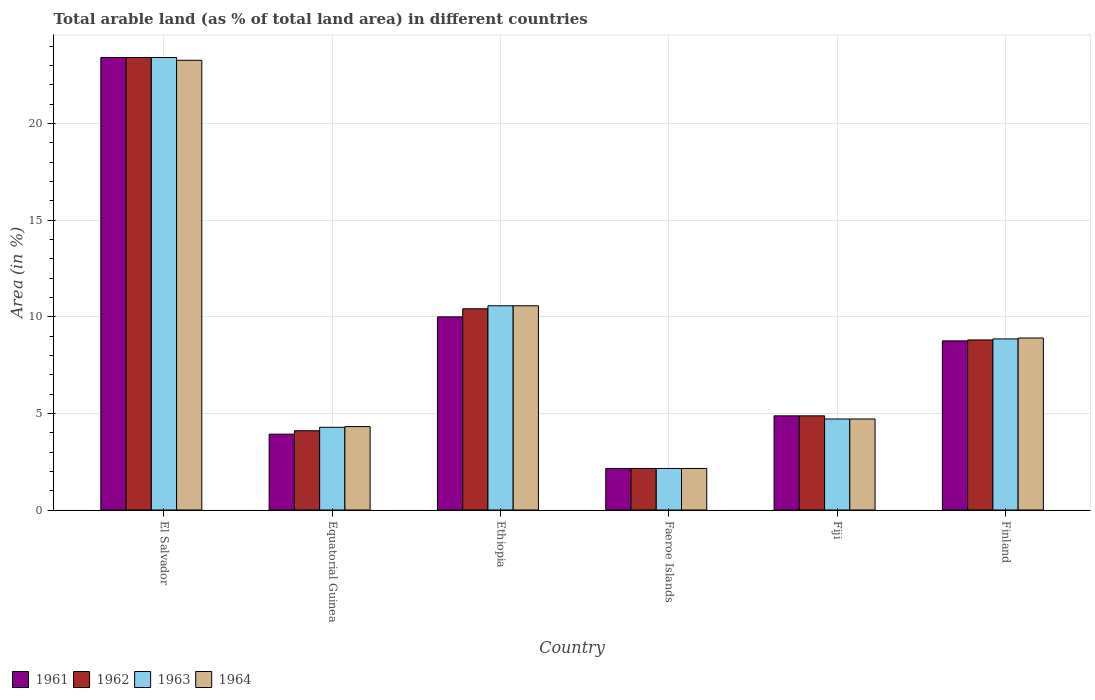What is the label of the 3rd group of bars from the left?
Make the answer very short. Ethiopia. In how many cases, is the number of bars for a given country not equal to the number of legend labels?
Give a very brief answer. 0. What is the percentage of arable land in 1963 in Fiji?
Your answer should be compact. 4.71. Across all countries, what is the maximum percentage of arable land in 1961?
Keep it short and to the point. 23.41. Across all countries, what is the minimum percentage of arable land in 1961?
Offer a very short reply. 2.15. In which country was the percentage of arable land in 1962 maximum?
Your answer should be compact. El Salvador. In which country was the percentage of arable land in 1961 minimum?
Provide a succinct answer. Faeroe Islands. What is the total percentage of arable land in 1964 in the graph?
Your answer should be very brief. 53.89. What is the difference between the percentage of arable land in 1964 in Fiji and that in Finland?
Keep it short and to the point. -4.19. What is the difference between the percentage of arable land in 1961 in El Salvador and the percentage of arable land in 1964 in Finland?
Your answer should be very brief. 14.51. What is the average percentage of arable land in 1963 per country?
Offer a terse response. 8.99. What is the difference between the percentage of arable land of/in 1964 and percentage of arable land of/in 1961 in El Salvador?
Ensure brevity in your answer.  -0.14. What is the ratio of the percentage of arable land in 1961 in Ethiopia to that in Finland?
Your answer should be compact. 1.14. Is the difference between the percentage of arable land in 1964 in El Salvador and Ethiopia greater than the difference between the percentage of arable land in 1961 in El Salvador and Ethiopia?
Offer a very short reply. No. What is the difference between the highest and the second highest percentage of arable land in 1961?
Make the answer very short. -1.24. What is the difference between the highest and the lowest percentage of arable land in 1963?
Provide a short and direct response. 21.26. What does the 1st bar from the left in Equatorial Guinea represents?
Offer a very short reply. 1961. What does the 4th bar from the right in Equatorial Guinea represents?
Your answer should be compact. 1961. How many countries are there in the graph?
Your response must be concise. 6. Does the graph contain any zero values?
Your response must be concise. No. Where does the legend appear in the graph?
Offer a very short reply. Bottom left. How many legend labels are there?
Keep it short and to the point. 4. How are the legend labels stacked?
Offer a terse response. Horizontal. What is the title of the graph?
Your answer should be very brief. Total arable land (as % of total land area) in different countries. Does "1990" appear as one of the legend labels in the graph?
Make the answer very short. No. What is the label or title of the X-axis?
Your response must be concise. Country. What is the label or title of the Y-axis?
Offer a very short reply. Area (in %). What is the Area (in %) of 1961 in El Salvador?
Provide a short and direct response. 23.41. What is the Area (in %) in 1962 in El Salvador?
Offer a terse response. 23.41. What is the Area (in %) in 1963 in El Salvador?
Ensure brevity in your answer.  23.41. What is the Area (in %) in 1964 in El Salvador?
Your answer should be very brief. 23.26. What is the Area (in %) in 1961 in Equatorial Guinea?
Provide a succinct answer. 3.92. What is the Area (in %) of 1962 in Equatorial Guinea?
Your response must be concise. 4.1. What is the Area (in %) of 1963 in Equatorial Guinea?
Offer a very short reply. 4.28. What is the Area (in %) of 1964 in Equatorial Guinea?
Your answer should be very brief. 4.31. What is the Area (in %) of 1961 in Ethiopia?
Give a very brief answer. 9.99. What is the Area (in %) in 1962 in Ethiopia?
Your response must be concise. 10.41. What is the Area (in %) in 1963 in Ethiopia?
Your answer should be compact. 10.56. What is the Area (in %) of 1964 in Ethiopia?
Your answer should be very brief. 10.56. What is the Area (in %) in 1961 in Faeroe Islands?
Your response must be concise. 2.15. What is the Area (in %) of 1962 in Faeroe Islands?
Provide a short and direct response. 2.15. What is the Area (in %) of 1963 in Faeroe Islands?
Ensure brevity in your answer.  2.15. What is the Area (in %) in 1964 in Faeroe Islands?
Offer a very short reply. 2.15. What is the Area (in %) of 1961 in Fiji?
Provide a succinct answer. 4.87. What is the Area (in %) of 1962 in Fiji?
Provide a succinct answer. 4.87. What is the Area (in %) of 1963 in Fiji?
Your answer should be compact. 4.71. What is the Area (in %) of 1964 in Fiji?
Keep it short and to the point. 4.71. What is the Area (in %) of 1961 in Finland?
Your response must be concise. 8.75. What is the Area (in %) in 1962 in Finland?
Give a very brief answer. 8.8. What is the Area (in %) of 1963 in Finland?
Ensure brevity in your answer.  8.85. What is the Area (in %) in 1964 in Finland?
Ensure brevity in your answer.  8.9. Across all countries, what is the maximum Area (in %) of 1961?
Your answer should be compact. 23.41. Across all countries, what is the maximum Area (in %) in 1962?
Your answer should be very brief. 23.41. Across all countries, what is the maximum Area (in %) in 1963?
Give a very brief answer. 23.41. Across all countries, what is the maximum Area (in %) of 1964?
Your answer should be very brief. 23.26. Across all countries, what is the minimum Area (in %) in 1961?
Ensure brevity in your answer.  2.15. Across all countries, what is the minimum Area (in %) in 1962?
Provide a succinct answer. 2.15. Across all countries, what is the minimum Area (in %) in 1963?
Your response must be concise. 2.15. Across all countries, what is the minimum Area (in %) of 1964?
Give a very brief answer. 2.15. What is the total Area (in %) of 1961 in the graph?
Keep it short and to the point. 53.09. What is the total Area (in %) in 1962 in the graph?
Ensure brevity in your answer.  53.73. What is the total Area (in %) of 1963 in the graph?
Your answer should be compact. 53.95. What is the total Area (in %) in 1964 in the graph?
Your response must be concise. 53.89. What is the difference between the Area (in %) in 1961 in El Salvador and that in Equatorial Guinea?
Offer a very short reply. 19.48. What is the difference between the Area (in %) of 1962 in El Salvador and that in Equatorial Guinea?
Provide a short and direct response. 19.31. What is the difference between the Area (in %) of 1963 in El Salvador and that in Equatorial Guinea?
Ensure brevity in your answer.  19.13. What is the difference between the Area (in %) in 1964 in El Salvador and that in Equatorial Guinea?
Give a very brief answer. 18.95. What is the difference between the Area (in %) of 1961 in El Salvador and that in Ethiopia?
Your response must be concise. 13.41. What is the difference between the Area (in %) in 1962 in El Salvador and that in Ethiopia?
Give a very brief answer. 13. What is the difference between the Area (in %) of 1963 in El Salvador and that in Ethiopia?
Your answer should be compact. 12.84. What is the difference between the Area (in %) in 1964 in El Salvador and that in Ethiopia?
Your answer should be very brief. 12.7. What is the difference between the Area (in %) of 1961 in El Salvador and that in Faeroe Islands?
Ensure brevity in your answer.  21.26. What is the difference between the Area (in %) of 1962 in El Salvador and that in Faeroe Islands?
Give a very brief answer. 21.26. What is the difference between the Area (in %) in 1963 in El Salvador and that in Faeroe Islands?
Your response must be concise. 21.26. What is the difference between the Area (in %) in 1964 in El Salvador and that in Faeroe Islands?
Give a very brief answer. 21.11. What is the difference between the Area (in %) in 1961 in El Salvador and that in Fiji?
Your answer should be very brief. 18.53. What is the difference between the Area (in %) in 1962 in El Salvador and that in Fiji?
Provide a short and direct response. 18.53. What is the difference between the Area (in %) of 1963 in El Salvador and that in Fiji?
Keep it short and to the point. 18.7. What is the difference between the Area (in %) in 1964 in El Salvador and that in Fiji?
Your response must be concise. 18.55. What is the difference between the Area (in %) in 1961 in El Salvador and that in Finland?
Provide a succinct answer. 14.66. What is the difference between the Area (in %) of 1962 in El Salvador and that in Finland?
Offer a very short reply. 14.61. What is the difference between the Area (in %) in 1963 in El Salvador and that in Finland?
Make the answer very short. 14.56. What is the difference between the Area (in %) in 1964 in El Salvador and that in Finland?
Provide a short and direct response. 14.37. What is the difference between the Area (in %) in 1961 in Equatorial Guinea and that in Ethiopia?
Offer a terse response. -6.07. What is the difference between the Area (in %) of 1962 in Equatorial Guinea and that in Ethiopia?
Provide a short and direct response. -6.31. What is the difference between the Area (in %) in 1963 in Equatorial Guinea and that in Ethiopia?
Give a very brief answer. -6.29. What is the difference between the Area (in %) of 1964 in Equatorial Guinea and that in Ethiopia?
Your response must be concise. -6.25. What is the difference between the Area (in %) in 1961 in Equatorial Guinea and that in Faeroe Islands?
Your response must be concise. 1.77. What is the difference between the Area (in %) in 1962 in Equatorial Guinea and that in Faeroe Islands?
Make the answer very short. 1.95. What is the difference between the Area (in %) of 1963 in Equatorial Guinea and that in Faeroe Islands?
Your response must be concise. 2.13. What is the difference between the Area (in %) of 1964 in Equatorial Guinea and that in Faeroe Islands?
Give a very brief answer. 2.16. What is the difference between the Area (in %) in 1961 in Equatorial Guinea and that in Fiji?
Your answer should be very brief. -0.95. What is the difference between the Area (in %) of 1962 in Equatorial Guinea and that in Fiji?
Give a very brief answer. -0.77. What is the difference between the Area (in %) in 1963 in Equatorial Guinea and that in Fiji?
Provide a short and direct response. -0.43. What is the difference between the Area (in %) in 1964 in Equatorial Guinea and that in Fiji?
Keep it short and to the point. -0.39. What is the difference between the Area (in %) in 1961 in Equatorial Guinea and that in Finland?
Your answer should be very brief. -4.83. What is the difference between the Area (in %) in 1962 in Equatorial Guinea and that in Finland?
Keep it short and to the point. -4.7. What is the difference between the Area (in %) in 1963 in Equatorial Guinea and that in Finland?
Offer a terse response. -4.57. What is the difference between the Area (in %) of 1964 in Equatorial Guinea and that in Finland?
Give a very brief answer. -4.58. What is the difference between the Area (in %) of 1961 in Ethiopia and that in Faeroe Islands?
Give a very brief answer. 7.84. What is the difference between the Area (in %) of 1962 in Ethiopia and that in Faeroe Islands?
Your response must be concise. 8.26. What is the difference between the Area (in %) in 1963 in Ethiopia and that in Faeroe Islands?
Your answer should be very brief. 8.41. What is the difference between the Area (in %) in 1964 in Ethiopia and that in Faeroe Islands?
Offer a terse response. 8.41. What is the difference between the Area (in %) of 1961 in Ethiopia and that in Fiji?
Your answer should be very brief. 5.12. What is the difference between the Area (in %) in 1962 in Ethiopia and that in Fiji?
Keep it short and to the point. 5.54. What is the difference between the Area (in %) in 1963 in Ethiopia and that in Fiji?
Your response must be concise. 5.86. What is the difference between the Area (in %) of 1964 in Ethiopia and that in Fiji?
Keep it short and to the point. 5.86. What is the difference between the Area (in %) of 1961 in Ethiopia and that in Finland?
Ensure brevity in your answer.  1.24. What is the difference between the Area (in %) of 1962 in Ethiopia and that in Finland?
Make the answer very short. 1.61. What is the difference between the Area (in %) of 1963 in Ethiopia and that in Finland?
Make the answer very short. 1.71. What is the difference between the Area (in %) of 1964 in Ethiopia and that in Finland?
Provide a short and direct response. 1.67. What is the difference between the Area (in %) in 1961 in Faeroe Islands and that in Fiji?
Offer a terse response. -2.72. What is the difference between the Area (in %) in 1962 in Faeroe Islands and that in Fiji?
Offer a very short reply. -2.72. What is the difference between the Area (in %) in 1963 in Faeroe Islands and that in Fiji?
Offer a very short reply. -2.56. What is the difference between the Area (in %) in 1964 in Faeroe Islands and that in Fiji?
Offer a very short reply. -2.56. What is the difference between the Area (in %) of 1961 in Faeroe Islands and that in Finland?
Your answer should be very brief. -6.6. What is the difference between the Area (in %) in 1962 in Faeroe Islands and that in Finland?
Give a very brief answer. -6.65. What is the difference between the Area (in %) in 1963 in Faeroe Islands and that in Finland?
Offer a very short reply. -6.7. What is the difference between the Area (in %) of 1964 in Faeroe Islands and that in Finland?
Your answer should be very brief. -6.75. What is the difference between the Area (in %) of 1961 in Fiji and that in Finland?
Your answer should be very brief. -3.88. What is the difference between the Area (in %) of 1962 in Fiji and that in Finland?
Offer a very short reply. -3.92. What is the difference between the Area (in %) in 1963 in Fiji and that in Finland?
Give a very brief answer. -4.14. What is the difference between the Area (in %) of 1964 in Fiji and that in Finland?
Make the answer very short. -4.19. What is the difference between the Area (in %) in 1961 in El Salvador and the Area (in %) in 1962 in Equatorial Guinea?
Provide a short and direct response. 19.31. What is the difference between the Area (in %) in 1961 in El Salvador and the Area (in %) in 1963 in Equatorial Guinea?
Your answer should be compact. 19.13. What is the difference between the Area (in %) of 1961 in El Salvador and the Area (in %) of 1964 in Equatorial Guinea?
Provide a succinct answer. 19.09. What is the difference between the Area (in %) of 1962 in El Salvador and the Area (in %) of 1963 in Equatorial Guinea?
Your answer should be compact. 19.13. What is the difference between the Area (in %) of 1962 in El Salvador and the Area (in %) of 1964 in Equatorial Guinea?
Provide a short and direct response. 19.09. What is the difference between the Area (in %) of 1963 in El Salvador and the Area (in %) of 1964 in Equatorial Guinea?
Make the answer very short. 19.09. What is the difference between the Area (in %) in 1961 in El Salvador and the Area (in %) in 1962 in Ethiopia?
Your response must be concise. 13. What is the difference between the Area (in %) in 1961 in El Salvador and the Area (in %) in 1963 in Ethiopia?
Keep it short and to the point. 12.84. What is the difference between the Area (in %) in 1961 in El Salvador and the Area (in %) in 1964 in Ethiopia?
Provide a succinct answer. 12.84. What is the difference between the Area (in %) of 1962 in El Salvador and the Area (in %) of 1963 in Ethiopia?
Offer a very short reply. 12.84. What is the difference between the Area (in %) in 1962 in El Salvador and the Area (in %) in 1964 in Ethiopia?
Provide a succinct answer. 12.84. What is the difference between the Area (in %) of 1963 in El Salvador and the Area (in %) of 1964 in Ethiopia?
Offer a very short reply. 12.84. What is the difference between the Area (in %) in 1961 in El Salvador and the Area (in %) in 1962 in Faeroe Islands?
Keep it short and to the point. 21.26. What is the difference between the Area (in %) of 1961 in El Salvador and the Area (in %) of 1963 in Faeroe Islands?
Make the answer very short. 21.26. What is the difference between the Area (in %) in 1961 in El Salvador and the Area (in %) in 1964 in Faeroe Islands?
Offer a very short reply. 21.26. What is the difference between the Area (in %) in 1962 in El Salvador and the Area (in %) in 1963 in Faeroe Islands?
Ensure brevity in your answer.  21.26. What is the difference between the Area (in %) of 1962 in El Salvador and the Area (in %) of 1964 in Faeroe Islands?
Give a very brief answer. 21.26. What is the difference between the Area (in %) in 1963 in El Salvador and the Area (in %) in 1964 in Faeroe Islands?
Provide a short and direct response. 21.26. What is the difference between the Area (in %) in 1961 in El Salvador and the Area (in %) in 1962 in Fiji?
Ensure brevity in your answer.  18.53. What is the difference between the Area (in %) in 1961 in El Salvador and the Area (in %) in 1963 in Fiji?
Your answer should be compact. 18.7. What is the difference between the Area (in %) of 1961 in El Salvador and the Area (in %) of 1964 in Fiji?
Provide a short and direct response. 18.7. What is the difference between the Area (in %) in 1962 in El Salvador and the Area (in %) in 1963 in Fiji?
Your response must be concise. 18.7. What is the difference between the Area (in %) in 1962 in El Salvador and the Area (in %) in 1964 in Fiji?
Your answer should be compact. 18.7. What is the difference between the Area (in %) in 1963 in El Salvador and the Area (in %) in 1964 in Fiji?
Your response must be concise. 18.7. What is the difference between the Area (in %) in 1961 in El Salvador and the Area (in %) in 1962 in Finland?
Give a very brief answer. 14.61. What is the difference between the Area (in %) in 1961 in El Salvador and the Area (in %) in 1963 in Finland?
Give a very brief answer. 14.56. What is the difference between the Area (in %) of 1961 in El Salvador and the Area (in %) of 1964 in Finland?
Your answer should be compact. 14.51. What is the difference between the Area (in %) of 1962 in El Salvador and the Area (in %) of 1963 in Finland?
Your answer should be compact. 14.56. What is the difference between the Area (in %) in 1962 in El Salvador and the Area (in %) in 1964 in Finland?
Your response must be concise. 14.51. What is the difference between the Area (in %) of 1963 in El Salvador and the Area (in %) of 1964 in Finland?
Your answer should be compact. 14.51. What is the difference between the Area (in %) of 1961 in Equatorial Guinea and the Area (in %) of 1962 in Ethiopia?
Ensure brevity in your answer.  -6.49. What is the difference between the Area (in %) in 1961 in Equatorial Guinea and the Area (in %) in 1963 in Ethiopia?
Give a very brief answer. -6.64. What is the difference between the Area (in %) of 1961 in Equatorial Guinea and the Area (in %) of 1964 in Ethiopia?
Provide a short and direct response. -6.64. What is the difference between the Area (in %) of 1962 in Equatorial Guinea and the Area (in %) of 1963 in Ethiopia?
Make the answer very short. -6.46. What is the difference between the Area (in %) in 1962 in Equatorial Guinea and the Area (in %) in 1964 in Ethiopia?
Your answer should be very brief. -6.46. What is the difference between the Area (in %) in 1963 in Equatorial Guinea and the Area (in %) in 1964 in Ethiopia?
Keep it short and to the point. -6.29. What is the difference between the Area (in %) in 1961 in Equatorial Guinea and the Area (in %) in 1962 in Faeroe Islands?
Give a very brief answer. 1.77. What is the difference between the Area (in %) of 1961 in Equatorial Guinea and the Area (in %) of 1963 in Faeroe Islands?
Keep it short and to the point. 1.77. What is the difference between the Area (in %) of 1961 in Equatorial Guinea and the Area (in %) of 1964 in Faeroe Islands?
Your answer should be compact. 1.77. What is the difference between the Area (in %) in 1962 in Equatorial Guinea and the Area (in %) in 1963 in Faeroe Islands?
Offer a terse response. 1.95. What is the difference between the Area (in %) in 1962 in Equatorial Guinea and the Area (in %) in 1964 in Faeroe Islands?
Your answer should be very brief. 1.95. What is the difference between the Area (in %) in 1963 in Equatorial Guinea and the Area (in %) in 1964 in Faeroe Islands?
Your answer should be very brief. 2.13. What is the difference between the Area (in %) in 1961 in Equatorial Guinea and the Area (in %) in 1962 in Fiji?
Give a very brief answer. -0.95. What is the difference between the Area (in %) of 1961 in Equatorial Guinea and the Area (in %) of 1963 in Fiji?
Offer a very short reply. -0.79. What is the difference between the Area (in %) of 1961 in Equatorial Guinea and the Area (in %) of 1964 in Fiji?
Provide a succinct answer. -0.79. What is the difference between the Area (in %) of 1962 in Equatorial Guinea and the Area (in %) of 1963 in Fiji?
Offer a very short reply. -0.61. What is the difference between the Area (in %) in 1962 in Equatorial Guinea and the Area (in %) in 1964 in Fiji?
Your answer should be very brief. -0.61. What is the difference between the Area (in %) of 1963 in Equatorial Guinea and the Area (in %) of 1964 in Fiji?
Offer a terse response. -0.43. What is the difference between the Area (in %) in 1961 in Equatorial Guinea and the Area (in %) in 1962 in Finland?
Provide a short and direct response. -4.87. What is the difference between the Area (in %) of 1961 in Equatorial Guinea and the Area (in %) of 1963 in Finland?
Your answer should be very brief. -4.93. What is the difference between the Area (in %) in 1961 in Equatorial Guinea and the Area (in %) in 1964 in Finland?
Your answer should be very brief. -4.97. What is the difference between the Area (in %) of 1962 in Equatorial Guinea and the Area (in %) of 1963 in Finland?
Your answer should be compact. -4.75. What is the difference between the Area (in %) of 1962 in Equatorial Guinea and the Area (in %) of 1964 in Finland?
Keep it short and to the point. -4.8. What is the difference between the Area (in %) in 1963 in Equatorial Guinea and the Area (in %) in 1964 in Finland?
Offer a very short reply. -4.62. What is the difference between the Area (in %) of 1961 in Ethiopia and the Area (in %) of 1962 in Faeroe Islands?
Your answer should be very brief. 7.84. What is the difference between the Area (in %) in 1961 in Ethiopia and the Area (in %) in 1963 in Faeroe Islands?
Give a very brief answer. 7.84. What is the difference between the Area (in %) of 1961 in Ethiopia and the Area (in %) of 1964 in Faeroe Islands?
Provide a short and direct response. 7.84. What is the difference between the Area (in %) in 1962 in Ethiopia and the Area (in %) in 1963 in Faeroe Islands?
Ensure brevity in your answer.  8.26. What is the difference between the Area (in %) of 1962 in Ethiopia and the Area (in %) of 1964 in Faeroe Islands?
Offer a very short reply. 8.26. What is the difference between the Area (in %) in 1963 in Ethiopia and the Area (in %) in 1964 in Faeroe Islands?
Your answer should be compact. 8.41. What is the difference between the Area (in %) in 1961 in Ethiopia and the Area (in %) in 1962 in Fiji?
Your answer should be very brief. 5.12. What is the difference between the Area (in %) of 1961 in Ethiopia and the Area (in %) of 1963 in Fiji?
Your answer should be compact. 5.28. What is the difference between the Area (in %) in 1961 in Ethiopia and the Area (in %) in 1964 in Fiji?
Your answer should be very brief. 5.28. What is the difference between the Area (in %) in 1962 in Ethiopia and the Area (in %) in 1963 in Fiji?
Your response must be concise. 5.7. What is the difference between the Area (in %) of 1962 in Ethiopia and the Area (in %) of 1964 in Fiji?
Offer a very short reply. 5.7. What is the difference between the Area (in %) of 1963 in Ethiopia and the Area (in %) of 1964 in Fiji?
Your answer should be very brief. 5.86. What is the difference between the Area (in %) in 1961 in Ethiopia and the Area (in %) in 1962 in Finland?
Make the answer very short. 1.2. What is the difference between the Area (in %) in 1961 in Ethiopia and the Area (in %) in 1963 in Finland?
Your answer should be very brief. 1.14. What is the difference between the Area (in %) of 1961 in Ethiopia and the Area (in %) of 1964 in Finland?
Provide a succinct answer. 1.09. What is the difference between the Area (in %) in 1962 in Ethiopia and the Area (in %) in 1963 in Finland?
Ensure brevity in your answer.  1.56. What is the difference between the Area (in %) in 1962 in Ethiopia and the Area (in %) in 1964 in Finland?
Keep it short and to the point. 1.51. What is the difference between the Area (in %) of 1963 in Ethiopia and the Area (in %) of 1964 in Finland?
Keep it short and to the point. 1.67. What is the difference between the Area (in %) of 1961 in Faeroe Islands and the Area (in %) of 1962 in Fiji?
Provide a succinct answer. -2.72. What is the difference between the Area (in %) of 1961 in Faeroe Islands and the Area (in %) of 1963 in Fiji?
Provide a short and direct response. -2.56. What is the difference between the Area (in %) in 1961 in Faeroe Islands and the Area (in %) in 1964 in Fiji?
Provide a short and direct response. -2.56. What is the difference between the Area (in %) of 1962 in Faeroe Islands and the Area (in %) of 1963 in Fiji?
Make the answer very short. -2.56. What is the difference between the Area (in %) of 1962 in Faeroe Islands and the Area (in %) of 1964 in Fiji?
Give a very brief answer. -2.56. What is the difference between the Area (in %) of 1963 in Faeroe Islands and the Area (in %) of 1964 in Fiji?
Offer a very short reply. -2.56. What is the difference between the Area (in %) in 1961 in Faeroe Islands and the Area (in %) in 1962 in Finland?
Your answer should be compact. -6.65. What is the difference between the Area (in %) of 1961 in Faeroe Islands and the Area (in %) of 1963 in Finland?
Provide a succinct answer. -6.7. What is the difference between the Area (in %) in 1961 in Faeroe Islands and the Area (in %) in 1964 in Finland?
Make the answer very short. -6.75. What is the difference between the Area (in %) of 1962 in Faeroe Islands and the Area (in %) of 1963 in Finland?
Give a very brief answer. -6.7. What is the difference between the Area (in %) in 1962 in Faeroe Islands and the Area (in %) in 1964 in Finland?
Ensure brevity in your answer.  -6.75. What is the difference between the Area (in %) of 1963 in Faeroe Islands and the Area (in %) of 1964 in Finland?
Provide a short and direct response. -6.75. What is the difference between the Area (in %) of 1961 in Fiji and the Area (in %) of 1962 in Finland?
Give a very brief answer. -3.92. What is the difference between the Area (in %) in 1961 in Fiji and the Area (in %) in 1963 in Finland?
Your answer should be compact. -3.98. What is the difference between the Area (in %) of 1961 in Fiji and the Area (in %) of 1964 in Finland?
Ensure brevity in your answer.  -4.02. What is the difference between the Area (in %) in 1962 in Fiji and the Area (in %) in 1963 in Finland?
Your answer should be compact. -3.98. What is the difference between the Area (in %) in 1962 in Fiji and the Area (in %) in 1964 in Finland?
Make the answer very short. -4.02. What is the difference between the Area (in %) in 1963 in Fiji and the Area (in %) in 1964 in Finland?
Ensure brevity in your answer.  -4.19. What is the average Area (in %) in 1961 per country?
Provide a short and direct response. 8.85. What is the average Area (in %) of 1962 per country?
Keep it short and to the point. 8.95. What is the average Area (in %) in 1963 per country?
Give a very brief answer. 8.99. What is the average Area (in %) of 1964 per country?
Provide a succinct answer. 8.98. What is the difference between the Area (in %) of 1961 and Area (in %) of 1962 in El Salvador?
Your response must be concise. 0. What is the difference between the Area (in %) of 1961 and Area (in %) of 1963 in El Salvador?
Offer a terse response. 0. What is the difference between the Area (in %) of 1961 and Area (in %) of 1964 in El Salvador?
Your answer should be compact. 0.14. What is the difference between the Area (in %) of 1962 and Area (in %) of 1964 in El Salvador?
Keep it short and to the point. 0.14. What is the difference between the Area (in %) in 1963 and Area (in %) in 1964 in El Salvador?
Ensure brevity in your answer.  0.14. What is the difference between the Area (in %) of 1961 and Area (in %) of 1962 in Equatorial Guinea?
Your response must be concise. -0.18. What is the difference between the Area (in %) in 1961 and Area (in %) in 1963 in Equatorial Guinea?
Offer a terse response. -0.36. What is the difference between the Area (in %) of 1961 and Area (in %) of 1964 in Equatorial Guinea?
Your answer should be compact. -0.39. What is the difference between the Area (in %) of 1962 and Area (in %) of 1963 in Equatorial Guinea?
Keep it short and to the point. -0.18. What is the difference between the Area (in %) in 1962 and Area (in %) in 1964 in Equatorial Guinea?
Offer a terse response. -0.21. What is the difference between the Area (in %) in 1963 and Area (in %) in 1964 in Equatorial Guinea?
Ensure brevity in your answer.  -0.04. What is the difference between the Area (in %) of 1961 and Area (in %) of 1962 in Ethiopia?
Give a very brief answer. -0.42. What is the difference between the Area (in %) of 1961 and Area (in %) of 1963 in Ethiopia?
Offer a very short reply. -0.57. What is the difference between the Area (in %) in 1961 and Area (in %) in 1964 in Ethiopia?
Offer a terse response. -0.57. What is the difference between the Area (in %) of 1962 and Area (in %) of 1963 in Ethiopia?
Provide a succinct answer. -0.16. What is the difference between the Area (in %) in 1962 and Area (in %) in 1964 in Ethiopia?
Offer a very short reply. -0.16. What is the difference between the Area (in %) of 1961 and Area (in %) of 1963 in Faeroe Islands?
Provide a short and direct response. 0. What is the difference between the Area (in %) in 1961 and Area (in %) in 1964 in Faeroe Islands?
Your answer should be very brief. 0. What is the difference between the Area (in %) in 1963 and Area (in %) in 1964 in Faeroe Islands?
Give a very brief answer. 0. What is the difference between the Area (in %) in 1961 and Area (in %) in 1962 in Fiji?
Offer a terse response. 0. What is the difference between the Area (in %) of 1961 and Area (in %) of 1963 in Fiji?
Offer a very short reply. 0.16. What is the difference between the Area (in %) in 1961 and Area (in %) in 1964 in Fiji?
Your answer should be compact. 0.16. What is the difference between the Area (in %) of 1962 and Area (in %) of 1963 in Fiji?
Keep it short and to the point. 0.16. What is the difference between the Area (in %) of 1962 and Area (in %) of 1964 in Fiji?
Your response must be concise. 0.16. What is the difference between the Area (in %) in 1961 and Area (in %) in 1962 in Finland?
Your response must be concise. -0.05. What is the difference between the Area (in %) of 1961 and Area (in %) of 1963 in Finland?
Provide a succinct answer. -0.1. What is the difference between the Area (in %) of 1961 and Area (in %) of 1964 in Finland?
Provide a succinct answer. -0.15. What is the difference between the Area (in %) of 1962 and Area (in %) of 1963 in Finland?
Ensure brevity in your answer.  -0.05. What is the difference between the Area (in %) in 1962 and Area (in %) in 1964 in Finland?
Provide a short and direct response. -0.1. What is the difference between the Area (in %) in 1963 and Area (in %) in 1964 in Finland?
Keep it short and to the point. -0.05. What is the ratio of the Area (in %) in 1961 in El Salvador to that in Equatorial Guinea?
Offer a very short reply. 5.97. What is the ratio of the Area (in %) in 1962 in El Salvador to that in Equatorial Guinea?
Give a very brief answer. 5.71. What is the ratio of the Area (in %) of 1963 in El Salvador to that in Equatorial Guinea?
Offer a terse response. 5.47. What is the ratio of the Area (in %) of 1964 in El Salvador to that in Equatorial Guinea?
Offer a very short reply. 5.39. What is the ratio of the Area (in %) in 1961 in El Salvador to that in Ethiopia?
Ensure brevity in your answer.  2.34. What is the ratio of the Area (in %) in 1962 in El Salvador to that in Ethiopia?
Keep it short and to the point. 2.25. What is the ratio of the Area (in %) in 1963 in El Salvador to that in Ethiopia?
Ensure brevity in your answer.  2.22. What is the ratio of the Area (in %) of 1964 in El Salvador to that in Ethiopia?
Provide a succinct answer. 2.2. What is the ratio of the Area (in %) of 1961 in El Salvador to that in Faeroe Islands?
Provide a succinct answer. 10.89. What is the ratio of the Area (in %) in 1962 in El Salvador to that in Faeroe Islands?
Your answer should be compact. 10.89. What is the ratio of the Area (in %) of 1963 in El Salvador to that in Faeroe Islands?
Your answer should be very brief. 10.89. What is the ratio of the Area (in %) of 1964 in El Salvador to that in Faeroe Islands?
Offer a terse response. 10.82. What is the ratio of the Area (in %) in 1961 in El Salvador to that in Fiji?
Offer a terse response. 4.8. What is the ratio of the Area (in %) of 1962 in El Salvador to that in Fiji?
Make the answer very short. 4.8. What is the ratio of the Area (in %) in 1963 in El Salvador to that in Fiji?
Your answer should be compact. 4.97. What is the ratio of the Area (in %) of 1964 in El Salvador to that in Fiji?
Offer a terse response. 4.94. What is the ratio of the Area (in %) in 1961 in El Salvador to that in Finland?
Your response must be concise. 2.68. What is the ratio of the Area (in %) in 1962 in El Salvador to that in Finland?
Offer a terse response. 2.66. What is the ratio of the Area (in %) of 1963 in El Salvador to that in Finland?
Your response must be concise. 2.64. What is the ratio of the Area (in %) of 1964 in El Salvador to that in Finland?
Offer a terse response. 2.61. What is the ratio of the Area (in %) of 1961 in Equatorial Guinea to that in Ethiopia?
Offer a terse response. 0.39. What is the ratio of the Area (in %) in 1962 in Equatorial Guinea to that in Ethiopia?
Make the answer very short. 0.39. What is the ratio of the Area (in %) in 1963 in Equatorial Guinea to that in Ethiopia?
Give a very brief answer. 0.41. What is the ratio of the Area (in %) in 1964 in Equatorial Guinea to that in Ethiopia?
Make the answer very short. 0.41. What is the ratio of the Area (in %) of 1961 in Equatorial Guinea to that in Faeroe Islands?
Give a very brief answer. 1.82. What is the ratio of the Area (in %) of 1962 in Equatorial Guinea to that in Faeroe Islands?
Offer a very short reply. 1.91. What is the ratio of the Area (in %) in 1963 in Equatorial Guinea to that in Faeroe Islands?
Provide a succinct answer. 1.99. What is the ratio of the Area (in %) in 1964 in Equatorial Guinea to that in Faeroe Islands?
Provide a succinct answer. 2.01. What is the ratio of the Area (in %) of 1961 in Equatorial Guinea to that in Fiji?
Provide a short and direct response. 0.81. What is the ratio of the Area (in %) in 1962 in Equatorial Guinea to that in Fiji?
Offer a terse response. 0.84. What is the ratio of the Area (in %) in 1963 in Equatorial Guinea to that in Fiji?
Provide a short and direct response. 0.91. What is the ratio of the Area (in %) of 1964 in Equatorial Guinea to that in Fiji?
Ensure brevity in your answer.  0.92. What is the ratio of the Area (in %) of 1961 in Equatorial Guinea to that in Finland?
Offer a terse response. 0.45. What is the ratio of the Area (in %) of 1962 in Equatorial Guinea to that in Finland?
Your answer should be very brief. 0.47. What is the ratio of the Area (in %) of 1963 in Equatorial Guinea to that in Finland?
Provide a short and direct response. 0.48. What is the ratio of the Area (in %) in 1964 in Equatorial Guinea to that in Finland?
Give a very brief answer. 0.48. What is the ratio of the Area (in %) of 1961 in Ethiopia to that in Faeroe Islands?
Provide a short and direct response. 4.65. What is the ratio of the Area (in %) of 1962 in Ethiopia to that in Faeroe Islands?
Ensure brevity in your answer.  4.84. What is the ratio of the Area (in %) in 1963 in Ethiopia to that in Faeroe Islands?
Your answer should be compact. 4.92. What is the ratio of the Area (in %) of 1964 in Ethiopia to that in Faeroe Islands?
Offer a terse response. 4.92. What is the ratio of the Area (in %) of 1961 in Ethiopia to that in Fiji?
Your answer should be compact. 2.05. What is the ratio of the Area (in %) in 1962 in Ethiopia to that in Fiji?
Keep it short and to the point. 2.14. What is the ratio of the Area (in %) of 1963 in Ethiopia to that in Fiji?
Ensure brevity in your answer.  2.24. What is the ratio of the Area (in %) of 1964 in Ethiopia to that in Fiji?
Provide a short and direct response. 2.24. What is the ratio of the Area (in %) in 1961 in Ethiopia to that in Finland?
Your answer should be very brief. 1.14. What is the ratio of the Area (in %) of 1962 in Ethiopia to that in Finland?
Ensure brevity in your answer.  1.18. What is the ratio of the Area (in %) in 1963 in Ethiopia to that in Finland?
Provide a short and direct response. 1.19. What is the ratio of the Area (in %) of 1964 in Ethiopia to that in Finland?
Your answer should be compact. 1.19. What is the ratio of the Area (in %) of 1961 in Faeroe Islands to that in Fiji?
Give a very brief answer. 0.44. What is the ratio of the Area (in %) in 1962 in Faeroe Islands to that in Fiji?
Offer a very short reply. 0.44. What is the ratio of the Area (in %) in 1963 in Faeroe Islands to that in Fiji?
Your answer should be compact. 0.46. What is the ratio of the Area (in %) in 1964 in Faeroe Islands to that in Fiji?
Offer a very short reply. 0.46. What is the ratio of the Area (in %) in 1961 in Faeroe Islands to that in Finland?
Offer a terse response. 0.25. What is the ratio of the Area (in %) of 1962 in Faeroe Islands to that in Finland?
Your answer should be very brief. 0.24. What is the ratio of the Area (in %) of 1963 in Faeroe Islands to that in Finland?
Your answer should be compact. 0.24. What is the ratio of the Area (in %) of 1964 in Faeroe Islands to that in Finland?
Offer a terse response. 0.24. What is the ratio of the Area (in %) in 1961 in Fiji to that in Finland?
Provide a succinct answer. 0.56. What is the ratio of the Area (in %) of 1962 in Fiji to that in Finland?
Offer a very short reply. 0.55. What is the ratio of the Area (in %) in 1963 in Fiji to that in Finland?
Provide a short and direct response. 0.53. What is the ratio of the Area (in %) in 1964 in Fiji to that in Finland?
Give a very brief answer. 0.53. What is the difference between the highest and the second highest Area (in %) of 1961?
Keep it short and to the point. 13.41. What is the difference between the highest and the second highest Area (in %) of 1962?
Your response must be concise. 13. What is the difference between the highest and the second highest Area (in %) of 1963?
Your response must be concise. 12.84. What is the difference between the highest and the second highest Area (in %) in 1964?
Provide a succinct answer. 12.7. What is the difference between the highest and the lowest Area (in %) in 1961?
Your answer should be very brief. 21.26. What is the difference between the highest and the lowest Area (in %) in 1962?
Provide a short and direct response. 21.26. What is the difference between the highest and the lowest Area (in %) of 1963?
Your response must be concise. 21.26. What is the difference between the highest and the lowest Area (in %) of 1964?
Provide a succinct answer. 21.11. 